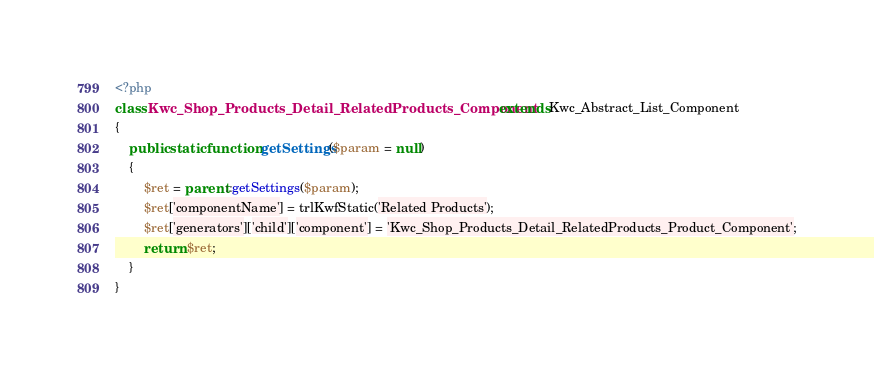<code> <loc_0><loc_0><loc_500><loc_500><_PHP_><?php
class Kwc_Shop_Products_Detail_RelatedProducts_Component extends Kwc_Abstract_List_Component
{
    public static function getSettings($param = null)
    {
        $ret = parent::getSettings($param);
        $ret['componentName'] = trlKwfStatic('Related Products');
        $ret['generators']['child']['component'] = 'Kwc_Shop_Products_Detail_RelatedProducts_Product_Component';
        return $ret;
    }
}
</code> 